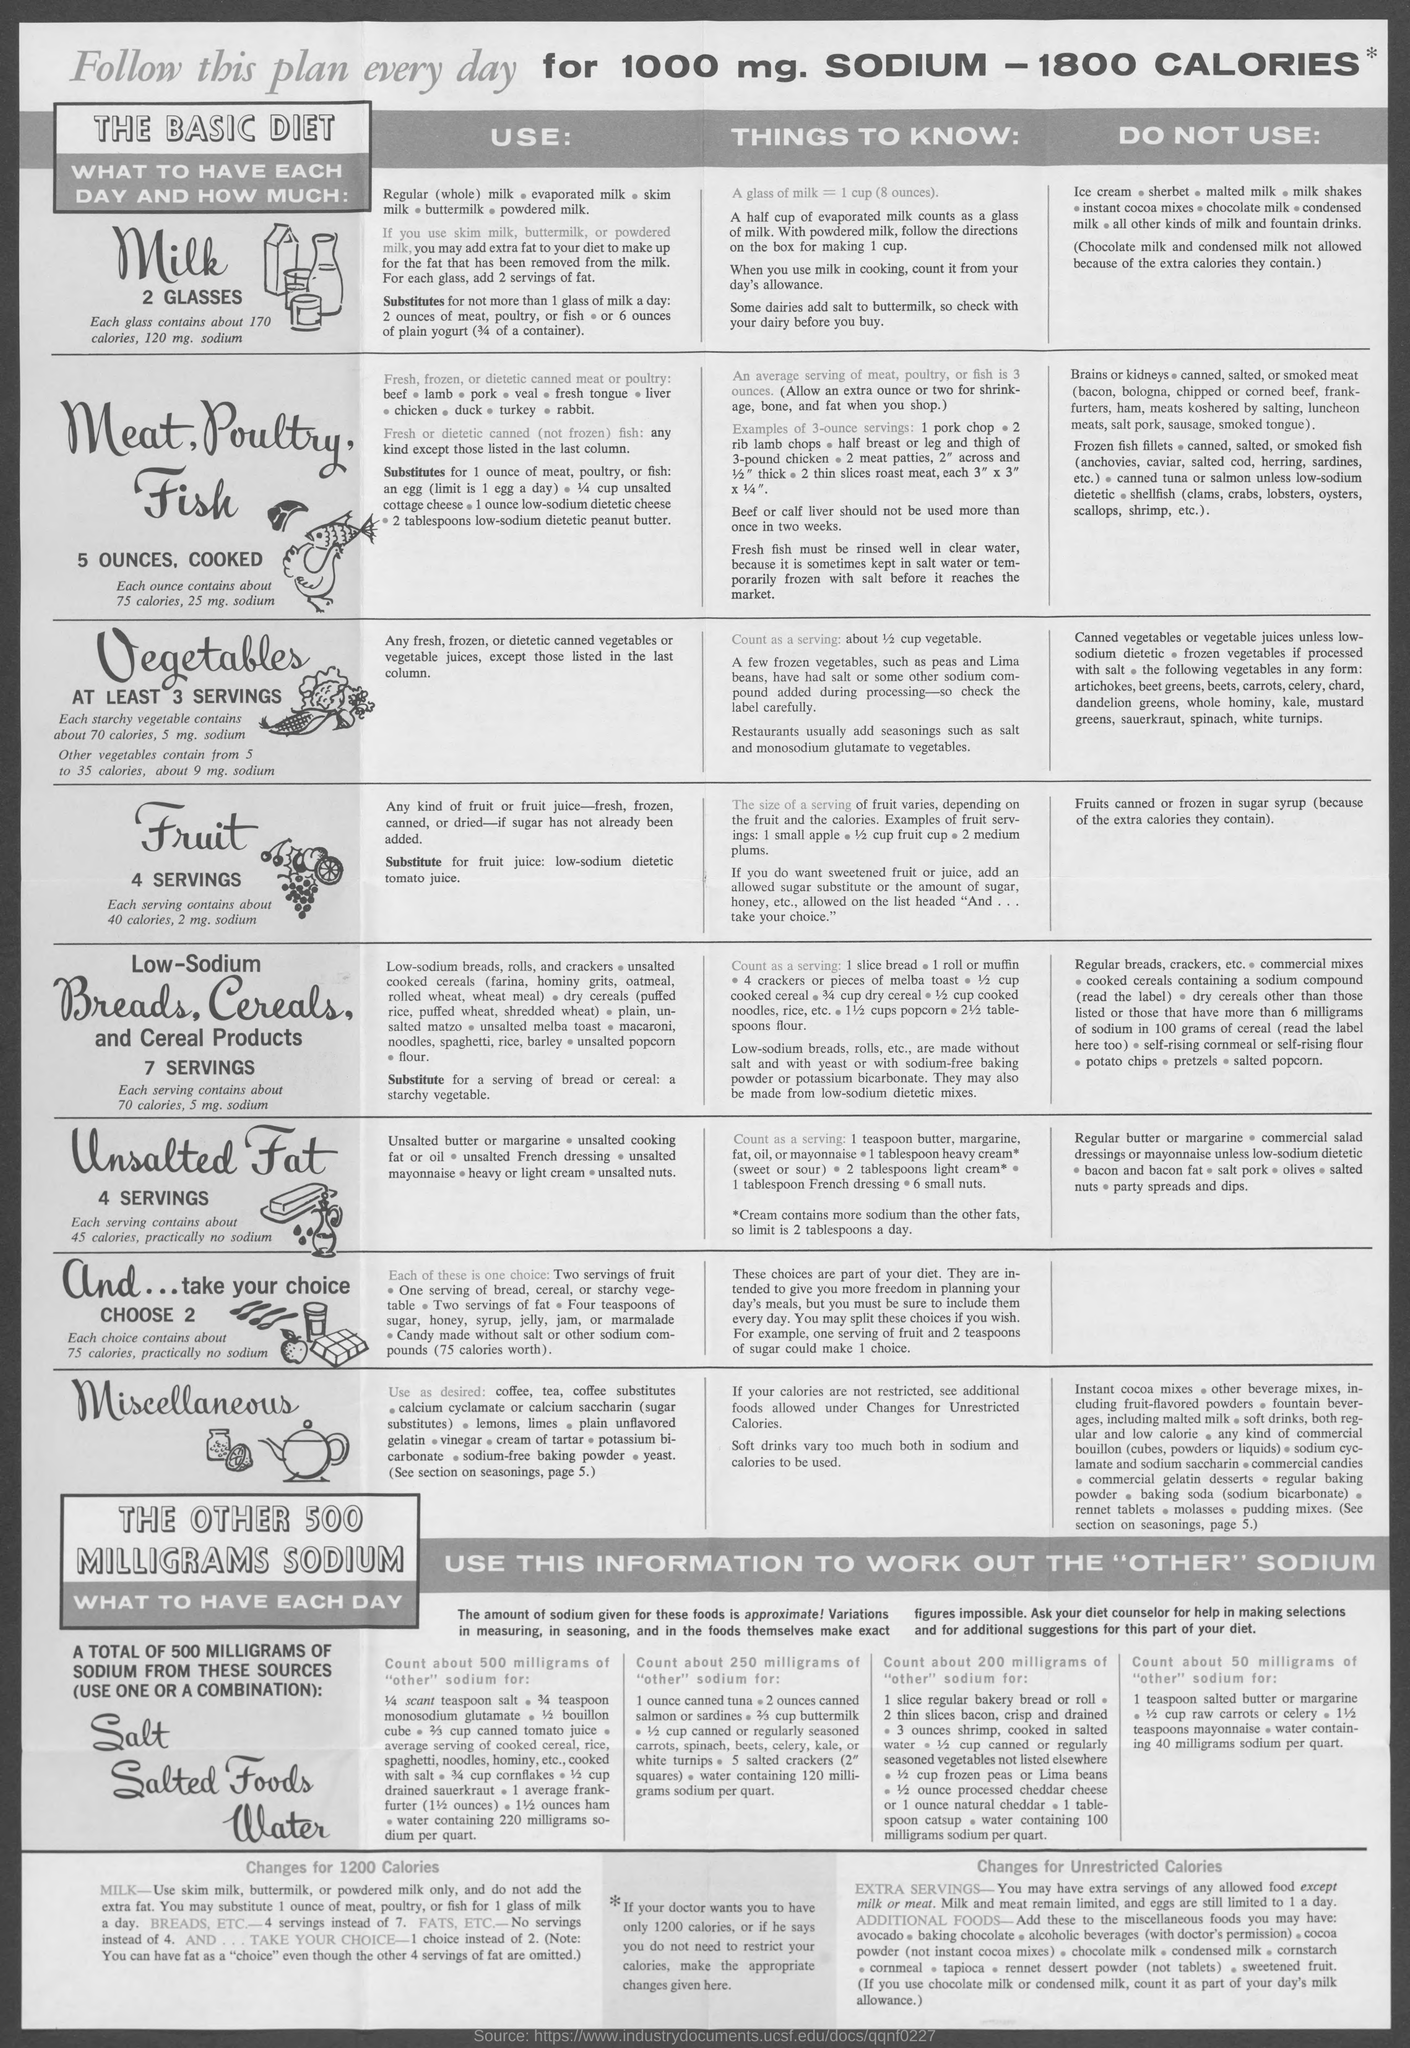How many glasses of Milk to have each day ?
Your response must be concise. 2 glasses. How many Calories for 1000 mg. Sodium ?
Your response must be concise. 1800 calories. 